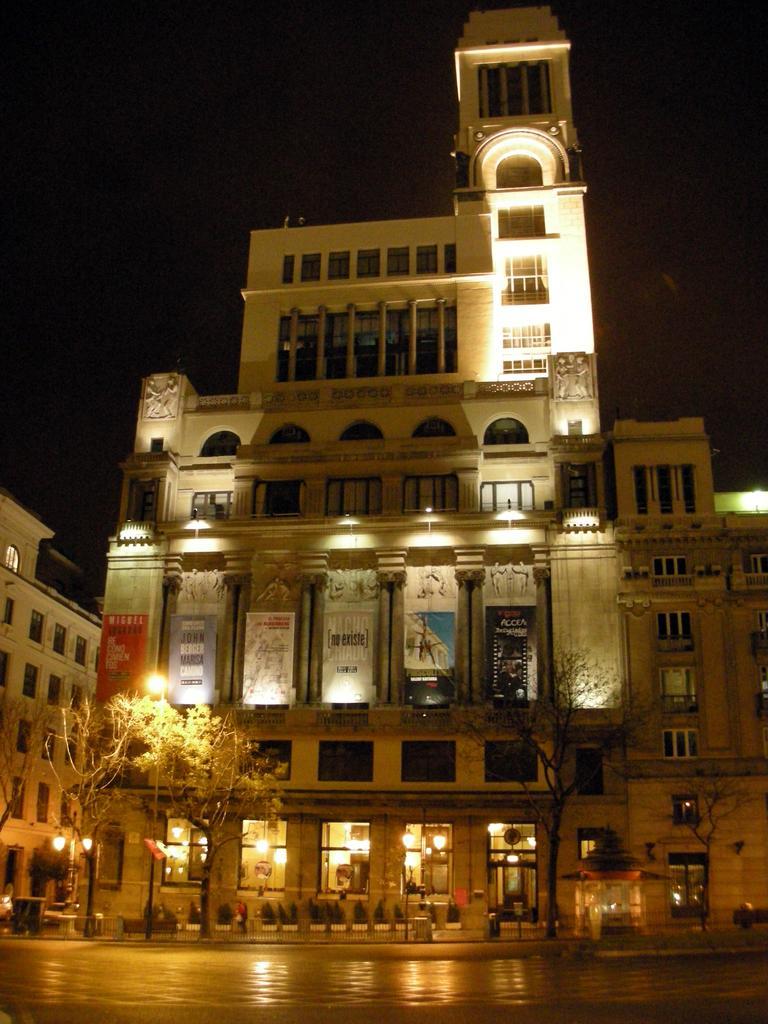Please provide a concise description of this image. Here in this picture we can see buildings present all over there and we can see windows on the buildings here and there and we can see doors also present and in the front we can see light posts present on the road here and there and we can see trees also present here and there. 